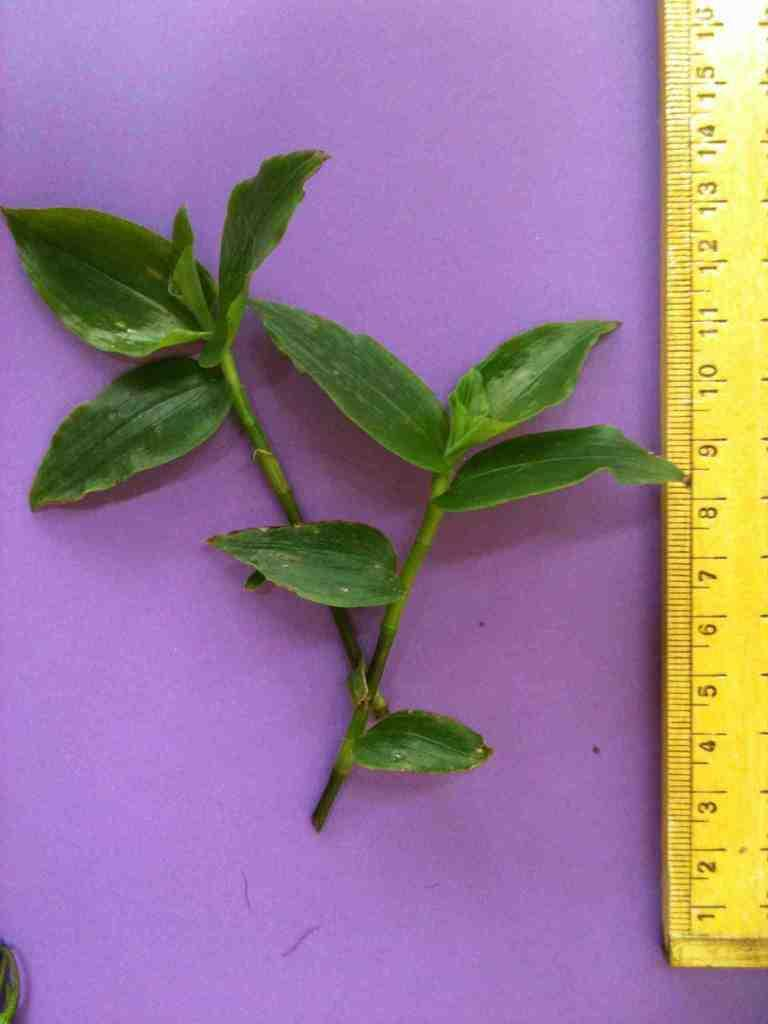<image>
Present a compact description of the photo's key features. A ruler beside a plant measuring about twelve centimeters. 